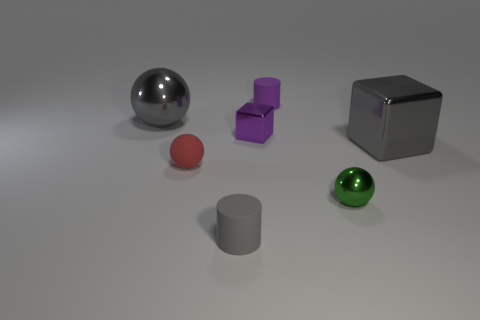Subtract all green balls. How many balls are left? 2 Subtract 0 cyan cylinders. How many objects are left? 7 Subtract all cylinders. How many objects are left? 5 Subtract 2 spheres. How many spheres are left? 1 Subtract all yellow spheres. Subtract all yellow cylinders. How many spheres are left? 3 Subtract all green spheres. How many yellow cylinders are left? 0 Subtract all big blocks. Subtract all tiny blue rubber blocks. How many objects are left? 6 Add 4 tiny matte objects. How many tiny matte objects are left? 7 Add 6 gray spheres. How many gray spheres exist? 7 Add 1 small purple metal cubes. How many objects exist? 8 